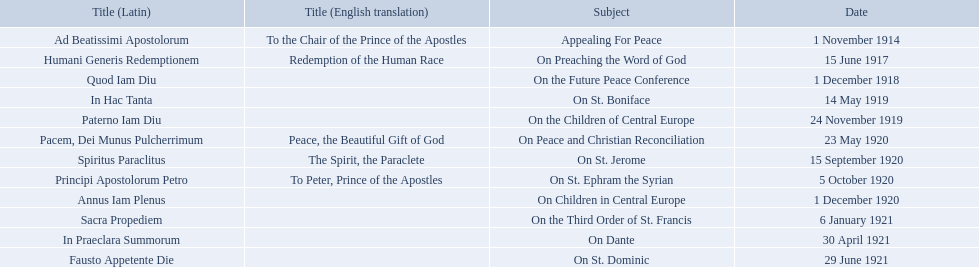What is the dates of the list of encyclicals of pope benedict xv? 1 November 1914, 15 June 1917, 1 December 1918, 14 May 1919, 24 November 1919, 23 May 1920, 15 September 1920, 5 October 1920, 1 December 1920, 6 January 1921, 30 April 1921, 29 June 1921. Of these dates, which subject was on 23 may 1920? On Peace and Christian Reconciliation. 